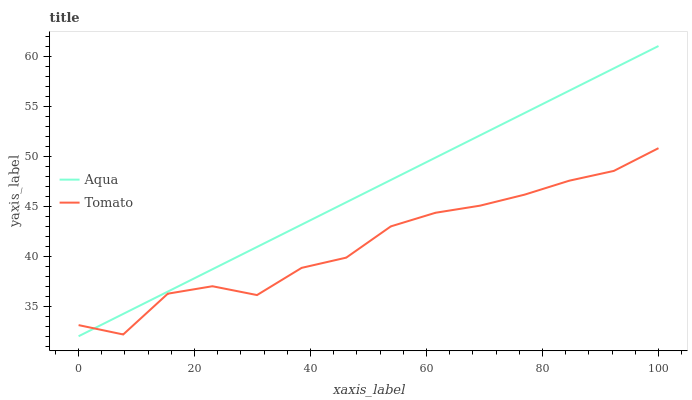Does Tomato have the minimum area under the curve?
Answer yes or no. Yes. Does Aqua have the maximum area under the curve?
Answer yes or no. Yes. Does Aqua have the minimum area under the curve?
Answer yes or no. No. Is Aqua the smoothest?
Answer yes or no. Yes. Is Tomato the roughest?
Answer yes or no. Yes. Is Aqua the roughest?
Answer yes or no. No. Does Aqua have the lowest value?
Answer yes or no. Yes. Does Aqua have the highest value?
Answer yes or no. Yes. Does Aqua intersect Tomato?
Answer yes or no. Yes. Is Aqua less than Tomato?
Answer yes or no. No. Is Aqua greater than Tomato?
Answer yes or no. No. 